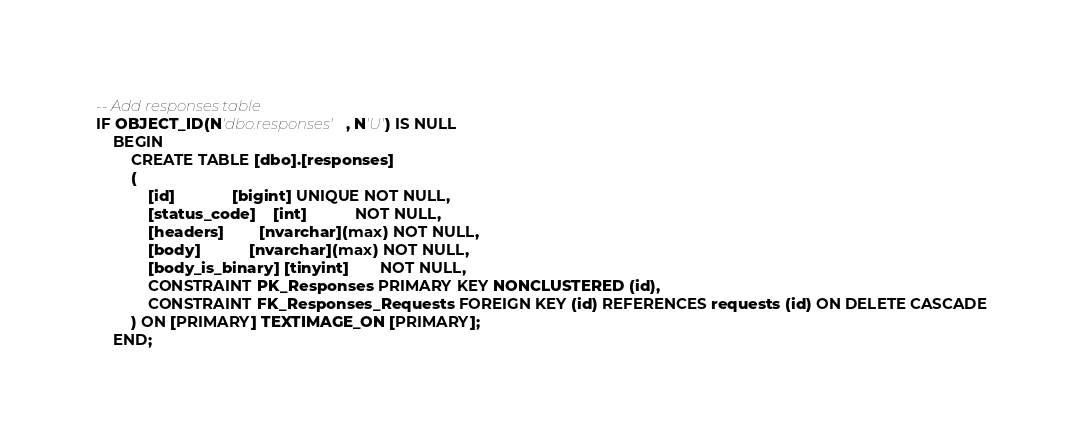<code> <loc_0><loc_0><loc_500><loc_500><_SQL_>-- Add responses table
IF OBJECT_ID(N'dbo.responses', N'U') IS NULL
    BEGIN
        CREATE TABLE [dbo].[responses]
        (
            [id]             [bigint] UNIQUE NOT NULL,
            [status_code]    [int]           NOT NULL,
            [headers]        [nvarchar](max) NOT NULL,
            [body]           [nvarchar](max) NOT NULL,
            [body_is_binary] [tinyint]       NOT NULL,
            CONSTRAINT PK_Responses PRIMARY KEY NONCLUSTERED (id),
            CONSTRAINT FK_Responses_Requests FOREIGN KEY (id) REFERENCES requests (id) ON DELETE CASCADE
        ) ON [PRIMARY] TEXTIMAGE_ON [PRIMARY];
    END;
</code> 